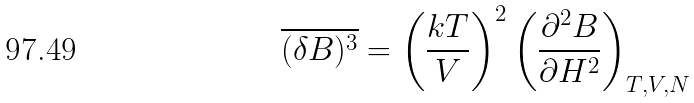<formula> <loc_0><loc_0><loc_500><loc_500>\overline { ( \delta B ) ^ { 3 } } = \left ( \frac { k T } { V } \right ) ^ { 2 } \left ( \frac { \partial ^ { 2 } B } { \partial H ^ { 2 } } \right ) _ { T , V , N }</formula> 